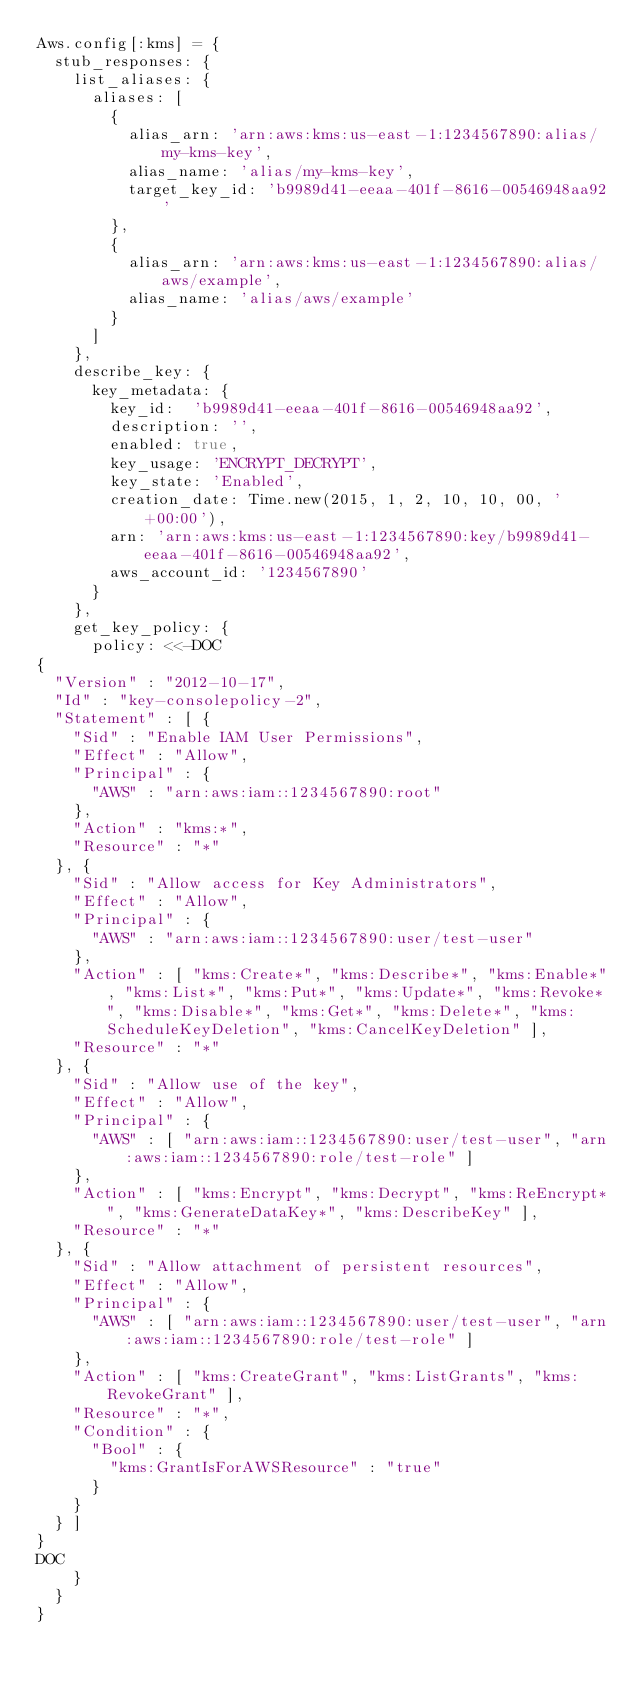Convert code to text. <code><loc_0><loc_0><loc_500><loc_500><_Ruby_>Aws.config[:kms] = {
  stub_responses: {
    list_aliases: {
      aliases: [
        {
          alias_arn: 'arn:aws:kms:us-east-1:1234567890:alias/my-kms-key',
          alias_name: 'alias/my-kms-key',
          target_key_id: 'b9989d41-eeaa-401f-8616-00546948aa92'
        },
        {
          alias_arn: 'arn:aws:kms:us-east-1:1234567890:alias/aws/example',
          alias_name: 'alias/aws/example'
        }
      ]
    },
    describe_key: {
      key_metadata: {
        key_id:  'b9989d41-eeaa-401f-8616-00546948aa92',
        description: '',
        enabled: true,
        key_usage: 'ENCRYPT_DECRYPT',
        key_state: 'Enabled',
        creation_date: Time.new(2015, 1, 2, 10, 10, 00, '+00:00'),
        arn: 'arn:aws:kms:us-east-1:1234567890:key/b9989d41-eeaa-401f-8616-00546948aa92',
        aws_account_id: '1234567890'
      }
    },
    get_key_policy: {
      policy: <<-DOC
{
  "Version" : "2012-10-17",
  "Id" : "key-consolepolicy-2",
  "Statement" : [ {
    "Sid" : "Enable IAM User Permissions",
    "Effect" : "Allow",
    "Principal" : {
      "AWS" : "arn:aws:iam::1234567890:root"
    },
    "Action" : "kms:*",
    "Resource" : "*"
  }, {
    "Sid" : "Allow access for Key Administrators",
    "Effect" : "Allow",
    "Principal" : {
      "AWS" : "arn:aws:iam::1234567890:user/test-user"
    },
    "Action" : [ "kms:Create*", "kms:Describe*", "kms:Enable*", "kms:List*", "kms:Put*", "kms:Update*", "kms:Revoke*", "kms:Disable*", "kms:Get*", "kms:Delete*", "kms:ScheduleKeyDeletion", "kms:CancelKeyDeletion" ],
    "Resource" : "*"
  }, {
    "Sid" : "Allow use of the key",
    "Effect" : "Allow",
    "Principal" : {
      "AWS" : [ "arn:aws:iam::1234567890:user/test-user", "arn:aws:iam::1234567890:role/test-role" ]
    },
    "Action" : [ "kms:Encrypt", "kms:Decrypt", "kms:ReEncrypt*", "kms:GenerateDataKey*", "kms:DescribeKey" ],
    "Resource" : "*"
  }, {
    "Sid" : "Allow attachment of persistent resources",
    "Effect" : "Allow",
    "Principal" : {
      "AWS" : [ "arn:aws:iam::1234567890:user/test-user", "arn:aws:iam::1234567890:role/test-role" ]
    },
    "Action" : [ "kms:CreateGrant", "kms:ListGrants", "kms:RevokeGrant" ],
    "Resource" : "*",
    "Condition" : {
      "Bool" : {
        "kms:GrantIsForAWSResource" : "true"
      }
    }
  } ]
}
DOC
    }
  }
}
</code> 